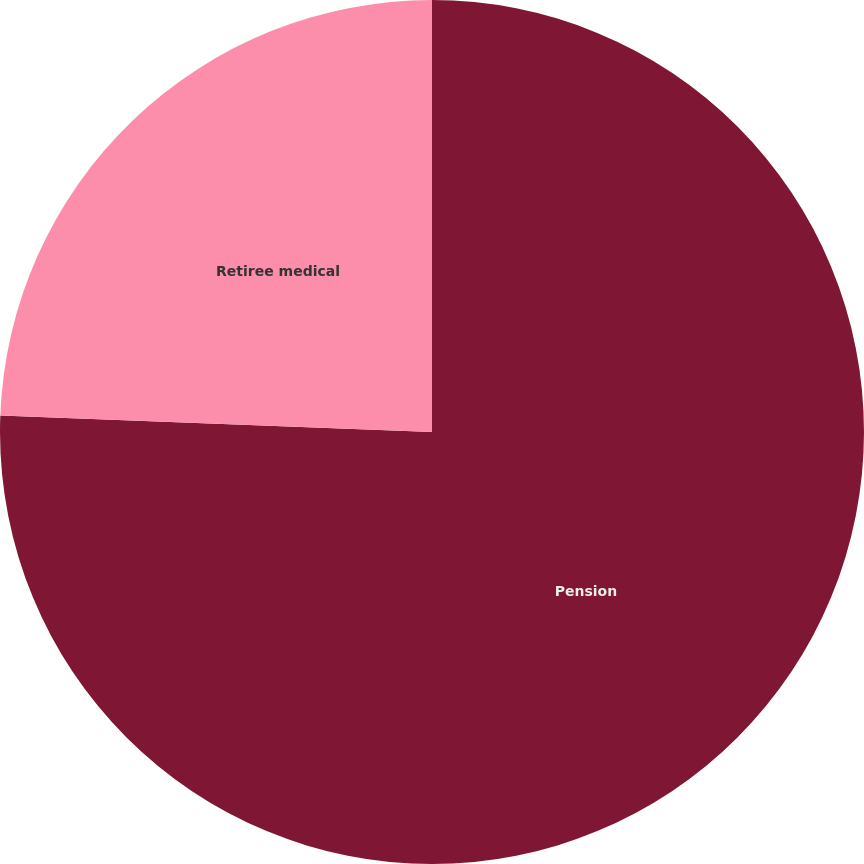<chart> <loc_0><loc_0><loc_500><loc_500><pie_chart><fcel>Pension<fcel>Retiree medical<nl><fcel>75.61%<fcel>24.39%<nl></chart> 